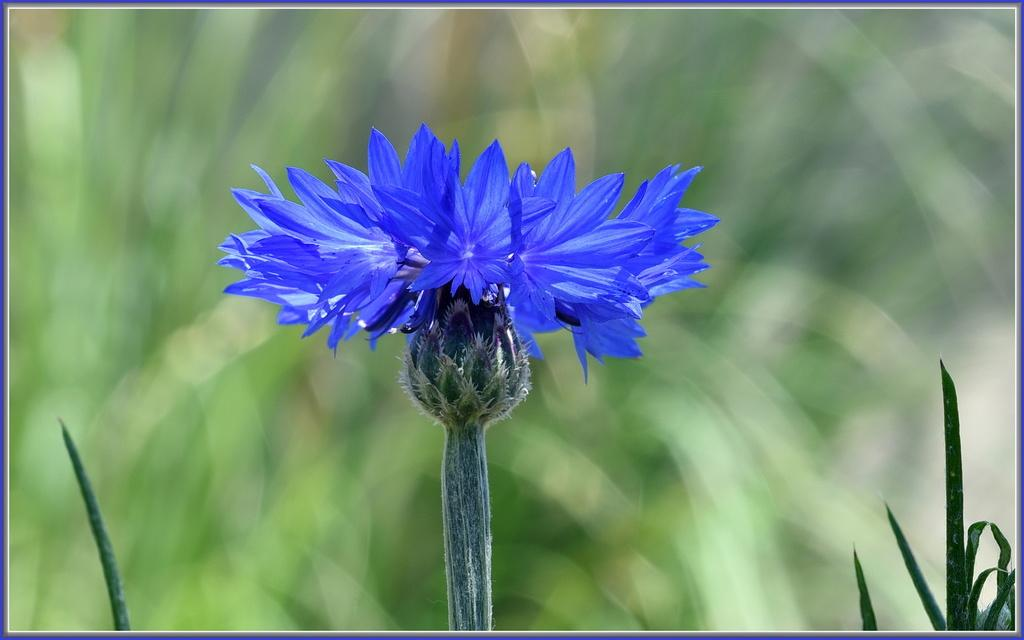What type of flower is present in the image? There is a blue color flower in the image. What is the flower a part of? The flower belongs to a plant. How would you describe the background of the image? The background of the image is blurred. What color is the background? The background color is green. What type of error can be seen in the image? There is no error present in the image; it is a clear photograph of a blue flower. 